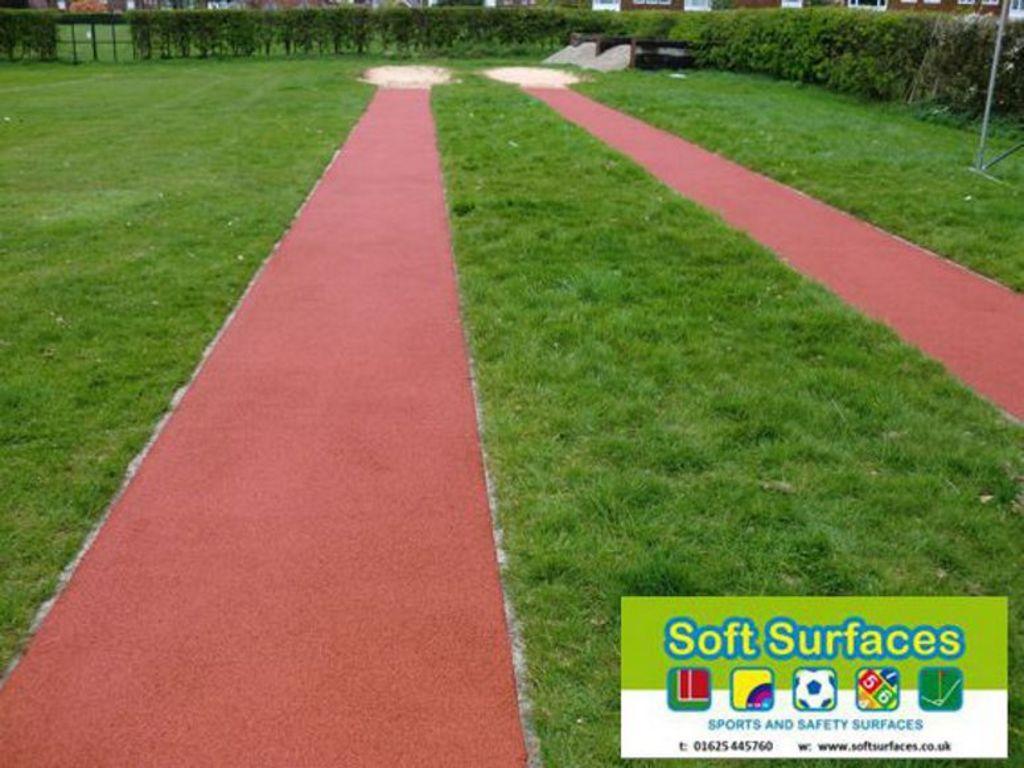Please provide a concise description of this image. In this image, we can see the ground. We can see some grass. We can see some plants and a pole. We can see the watermark. 